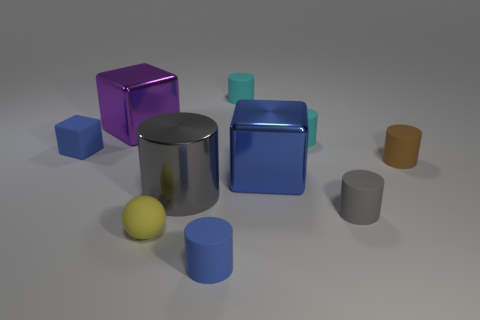Subtract all brown cylinders. How many cylinders are left? 5 Subtract all large cylinders. How many cylinders are left? 5 Subtract 3 cylinders. How many cylinders are left? 3 Subtract all purple cylinders. Subtract all purple balls. How many cylinders are left? 6 Subtract all cylinders. How many objects are left? 4 Add 7 blue shiny blocks. How many blue shiny blocks exist? 8 Subtract 0 purple cylinders. How many objects are left? 10 Subtract all large rubber things. Subtract all tiny cylinders. How many objects are left? 5 Add 1 gray shiny things. How many gray shiny things are left? 2 